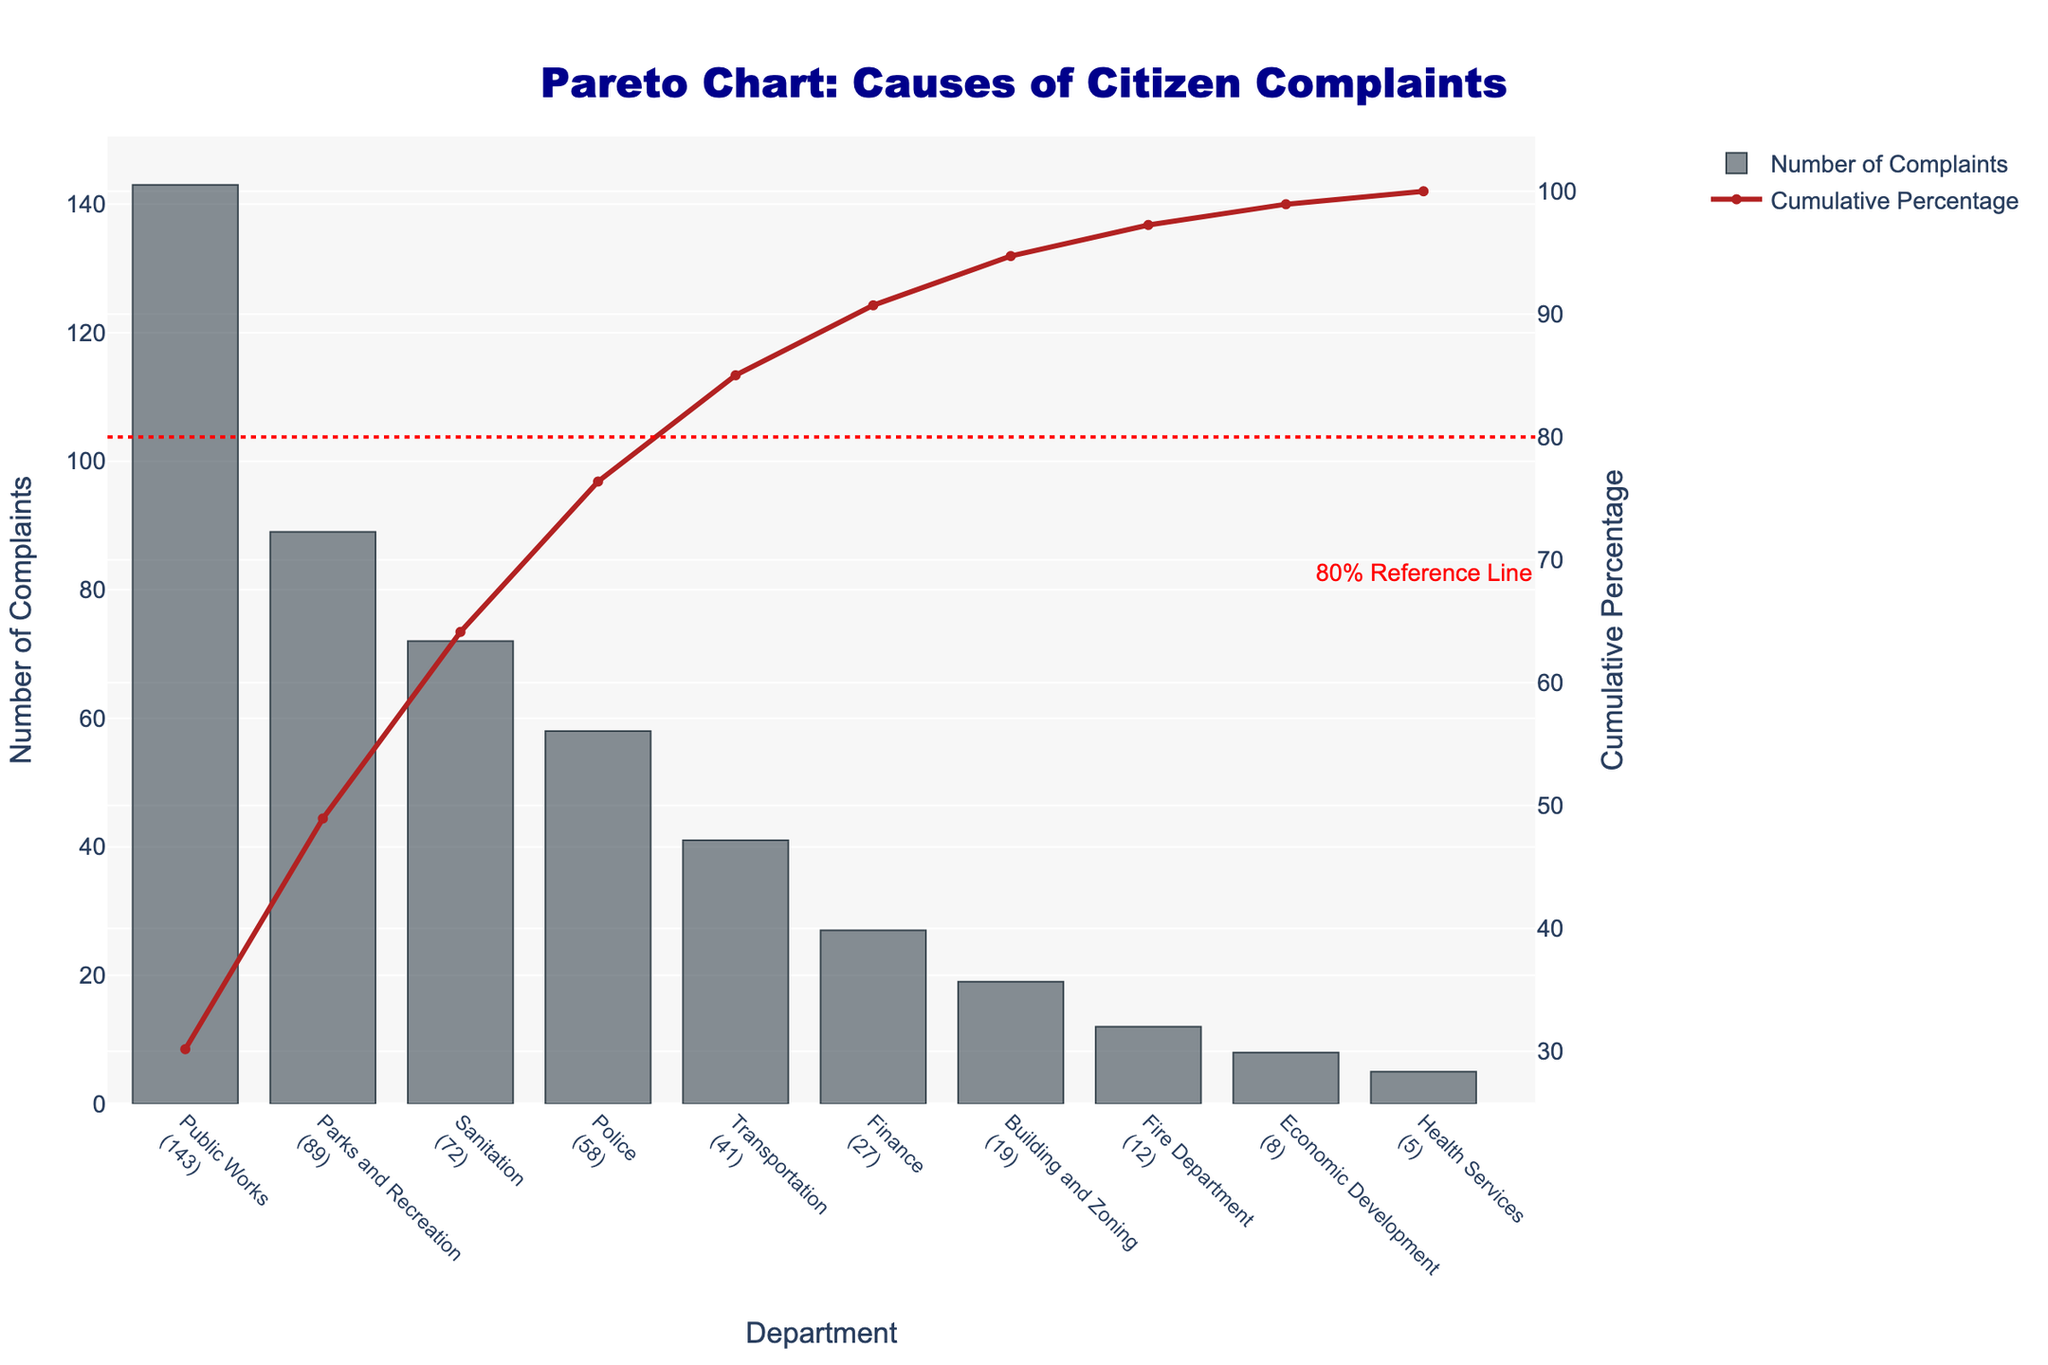What's the title of the chart? The title is usually located at the top of the chart, which displays the main subject or summarized essence of the chart. The title of the chart reads "Pareto Chart: Causes of Citizen Complaints," indicating that the chart visualizes the causes of complaints to the mayor's office, categorized by department.
Answer: Pareto Chart: Causes of Citizen Complaints Which department has the highest number of complaints? To answer this, look for the tallest bar in the bar chart component. The department corresponding to this bar will be the one with the highest number of complaints. The bar for "Public Works" is the tallest, indicating that it has the most complaints.
Answer: Public Works What is the cumulative percentage for the Finance department? Locate the "Finance" department on the x-axis, then find its corresponding point on the cumulative percentage line (firebrick color). The y-value of this point on the secondary y-axis will give the cumulative percentage. For "Finance," this value is around 85%.
Answer: Around 85% How many complaints correspond to the top 3 departments? Identify the top 3 departments with the highest bars: "Public Works" (143), "Parks and Recreation" (89), and "Sanitation" (72). Then, add these values: 143 + 89 + 72 = 304. The top 3 departments have a total of 304 complaints.
Answer: 304 Which department is the 80% reference line closest to on the cumulative percentage line? Find the 80% reference line on the secondary y-axis. Trace horizontally from this line to intersect the cumulative percentage line (firebrick color). The nearest department on the x-axis will be the answer. This line is closest to "Finance."
Answer: Finance What's the sum of complaints for Transportation and Sanitation departments? Identify the number of complaints for "Transportation" (41) and "Sanitation" (72) departments, then sum these values: 41 + 72 = 113.
Answer: 113 Which departments collectively account for at least 80% of the complaints? The cumulative percentage line represents the collective contribution of departments. Track up to 80% on the secondary y-axis and find the corresponding departments. Collectively, "Public Works," "Parks and Recreation," "Sanitation," "Police," and "Transportation" account for around 80% of the complaints.
Answer: Public Works, Parks and Recreation, Sanitation, Police, and Transportation What’s the difference in the number of complaints between Parks and Recreation and Police departments? Locate the number of complaints for "Parks and Recreation" (89) and "Police" (58) departments. Subtract the lower value from the higher value: 89 - 58 = 31.
Answer: 31 Which department has the least number of complaints? Look for the shortest bar in the bar chart component. The department corresponding to this bar is the "Health Services" department with 5 complaints.
Answer: Health Services What cumulative percentage does the top department contribute? The top department is "Public Works" with the highest number of complaints. The corresponding cumulative percentage for this department is the value at the end of its bar on the secondary y-axis (around 28%).
Answer: Around 28% 